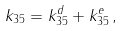Convert formula to latex. <formula><loc_0><loc_0><loc_500><loc_500>k _ { 3 5 } = k _ { 3 5 } ^ { d } + k _ { 3 5 } ^ { e } \, ,</formula> 